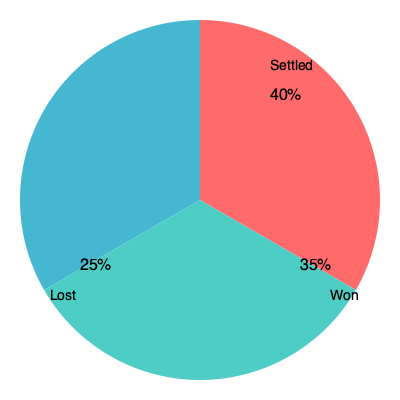As a lawyer analyzing your firm's performance, you review a pie chart showing the outcomes of 200 legal cases handled by your team last year. If the percentage of cases won is 35%, how many cases were settled? To solve this problem, we'll follow these steps:

1. Understand the given information:
   - Total cases: 200
   - Percentage of cases won: 35%
   - The pie chart shows three categories: Settled, Won, and Lost

2. Identify the percentage of settled cases from the pie chart:
   - Settled cases: 40%

3. Calculate the number of settled cases:
   - Number of settled cases = (Percentage of settled cases × Total cases) ÷ 100
   - Number of settled cases = (40 × 200) ÷ 100
   - Number of settled cases = 8000 ÷ 100
   - Number of settled cases = 80

Therefore, 80 cases were settled.
Answer: 80 cases 